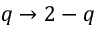Convert formula to latex. <formula><loc_0><loc_0><loc_500><loc_500>q \to 2 - q</formula> 